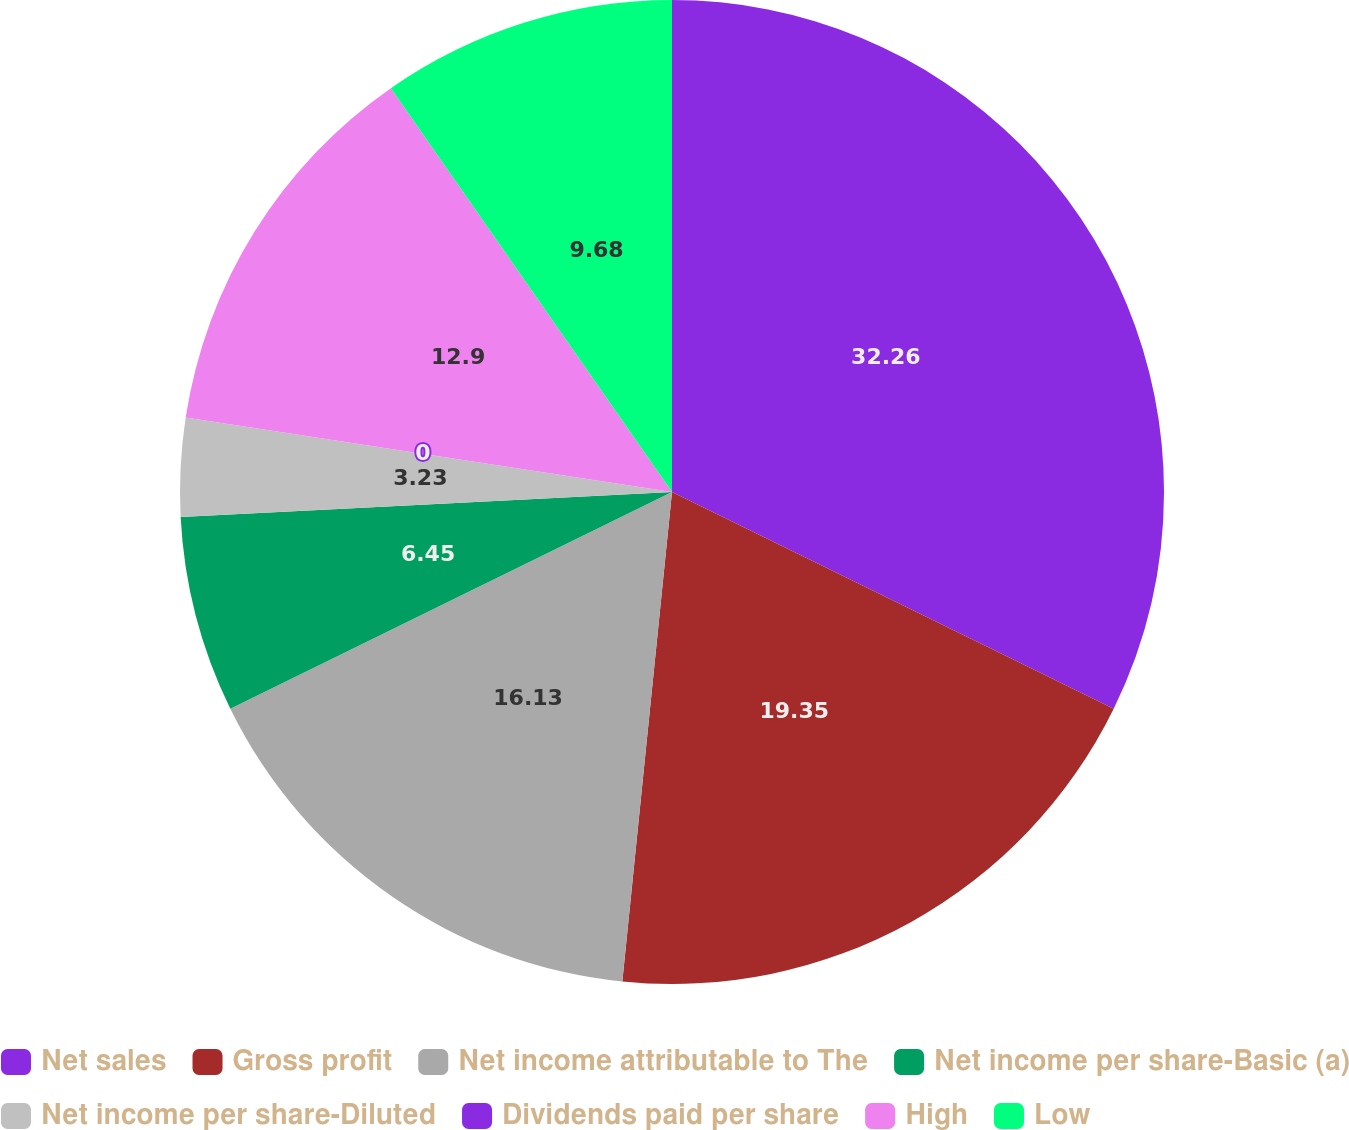Convert chart. <chart><loc_0><loc_0><loc_500><loc_500><pie_chart><fcel>Net sales<fcel>Gross profit<fcel>Net income attributable to The<fcel>Net income per share-Basic (a)<fcel>Net income per share-Diluted<fcel>Dividends paid per share<fcel>High<fcel>Low<nl><fcel>32.26%<fcel>19.35%<fcel>16.13%<fcel>6.45%<fcel>3.23%<fcel>0.0%<fcel>12.9%<fcel>9.68%<nl></chart> 